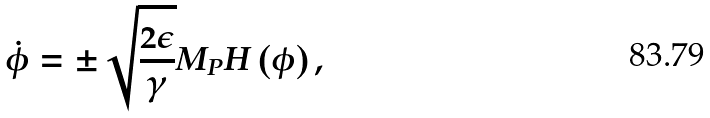<formula> <loc_0><loc_0><loc_500><loc_500>\dot { \phi } = \pm \sqrt { \frac { 2 \epsilon } { \gamma } } M _ { P } H \left ( \phi \right ) ,</formula> 